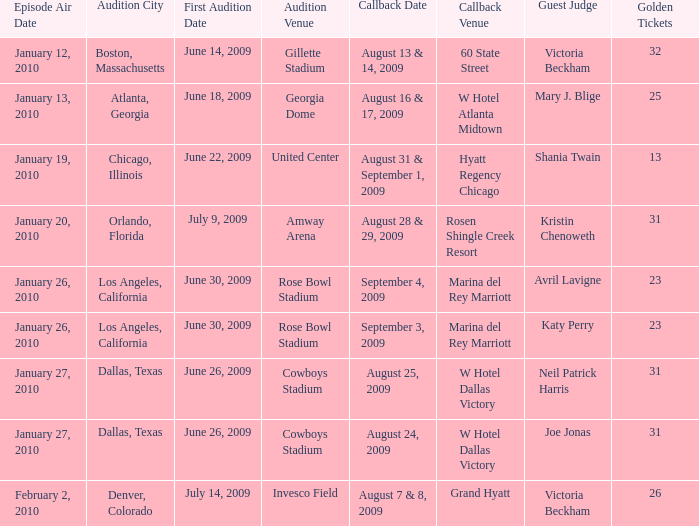Specify the audition town for hyatt regency chicago. Chicago, Illinois. 